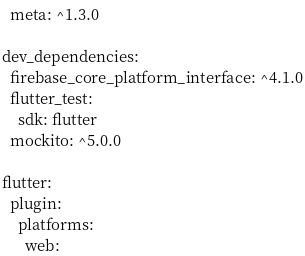<code> <loc_0><loc_0><loc_500><loc_500><_YAML_>  meta: ^1.3.0

dev_dependencies:
  firebase_core_platform_interface: ^4.1.0
  flutter_test:
    sdk: flutter
  mockito: ^5.0.0

flutter:
  plugin:
    platforms:
      web:</code> 